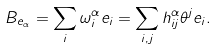<formula> <loc_0><loc_0><loc_500><loc_500>B _ { e _ { \alpha } } = \sum _ { i } \omega ^ { \alpha } _ { i } e _ { i } = \sum _ { i , j } h ^ { \alpha } _ { i j } \theta ^ { j } e _ { i } .</formula> 